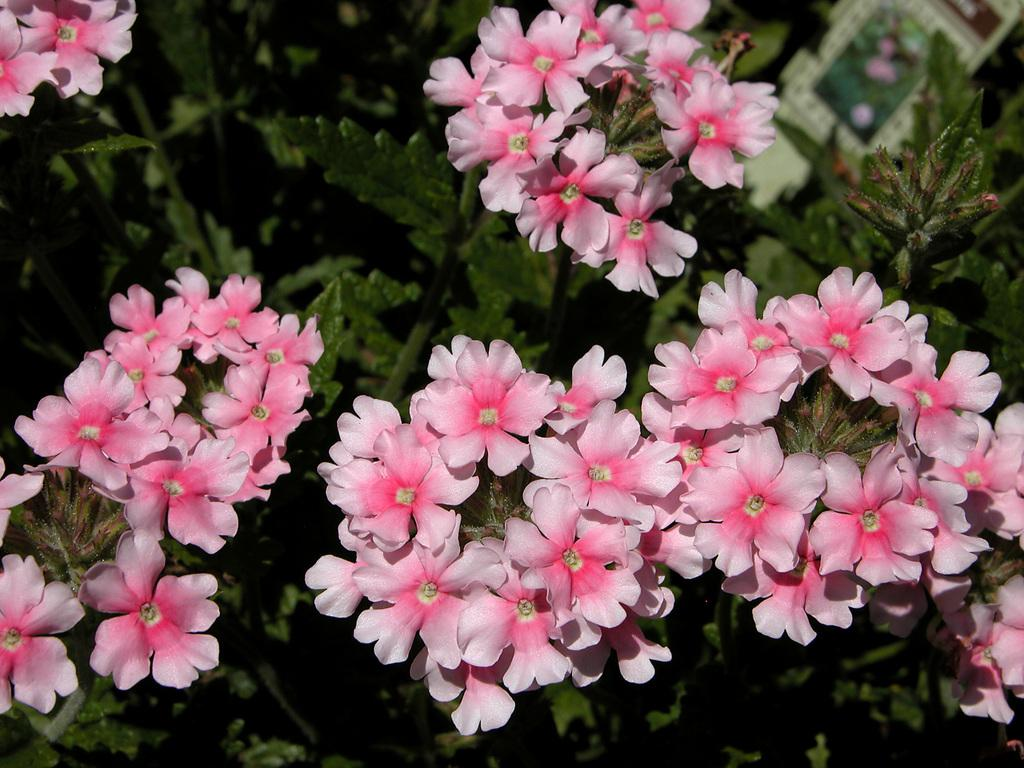What type of flora can be seen in the image? There are flowers in the image. What color are the flowers? The flowers are pink in color. What else can be seen in the background of the image? There are plants in the background of the image. Is there a cave visible in the image? No, there is no cave present in the image. What type of edge can be seen on the flowers in the image? The flowers in the image do not have an edge, as they are depicted as whole blooms. 